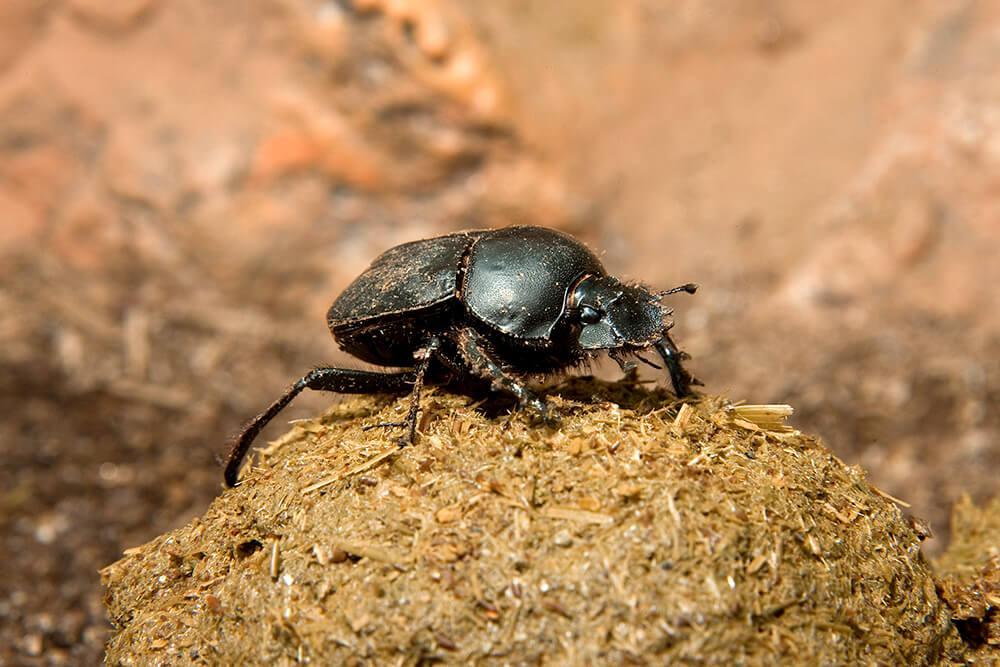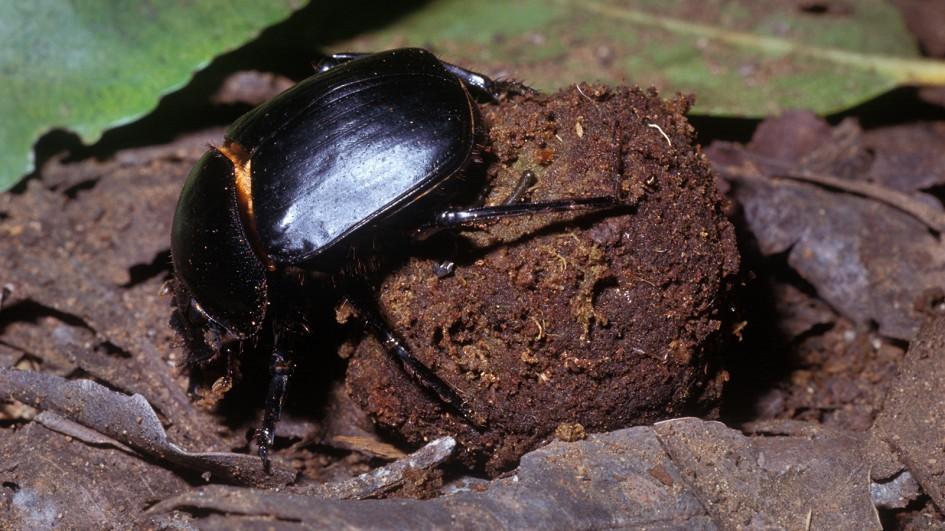The first image is the image on the left, the second image is the image on the right. For the images displayed, is the sentence "There are at least two insects in the image on the right." factually correct? Answer yes or no. No. The first image is the image on the left, the second image is the image on the right. Given the left and right images, does the statement "An image shows more than one beetle by a shape made of dung." hold true? Answer yes or no. No. The first image is the image on the left, the second image is the image on the right. Analyze the images presented: Is the assertion "An image shows a beetle atop a dung ball, so its body is parallel with the ground." valid? Answer yes or no. Yes. 